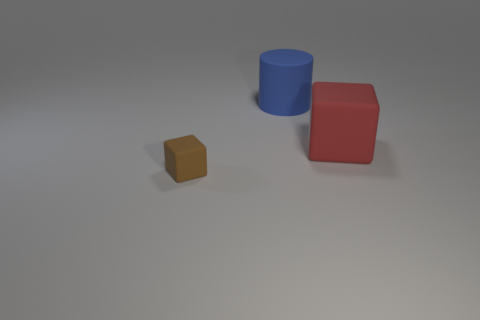Is the number of tiny brown blocks that are in front of the red object greater than the number of large matte cylinders that are left of the big cylinder? In the image, there is a single tiny brown block in front of the red cube. To the left of the large blue cylinder, there are no cylinders at all. Therefore, the number of tiny brown blocks in front of the red object, which is one, is indeed greater than the number of large matte cylinders to the left of the large cylinder, as there are none. 